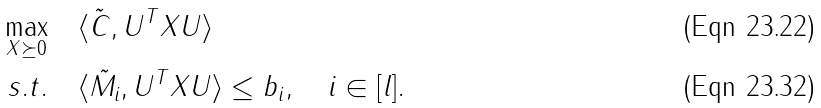Convert formula to latex. <formula><loc_0><loc_0><loc_500><loc_500>\max _ { X \succeq 0 } & \quad \langle \tilde { C } , U ^ { T } X U \rangle \\ s . t . & \quad \langle \tilde { M _ { i } } , U ^ { T } X U \rangle \leq b _ { i } , \quad i \in [ l ] .</formula> 